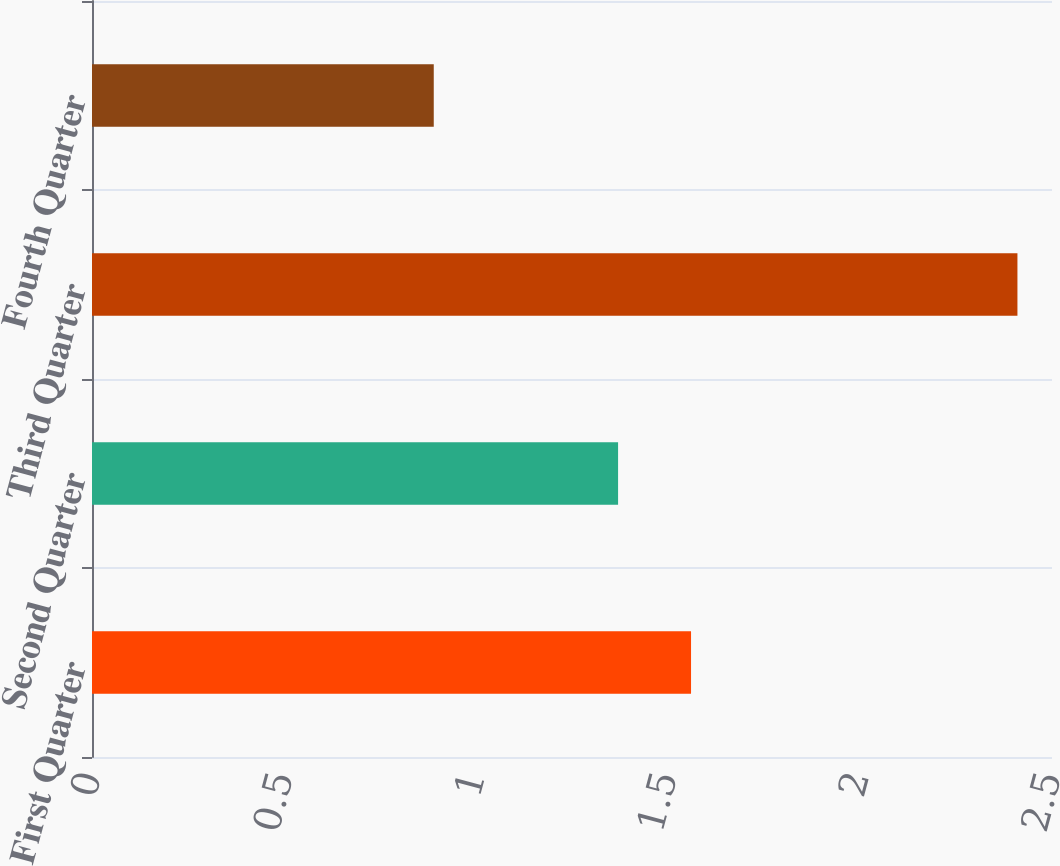Convert chart. <chart><loc_0><loc_0><loc_500><loc_500><bar_chart><fcel>First Quarter<fcel>Second Quarter<fcel>Third Quarter<fcel>Fourth Quarter<nl><fcel>1.56<fcel>1.37<fcel>2.41<fcel>0.89<nl></chart> 